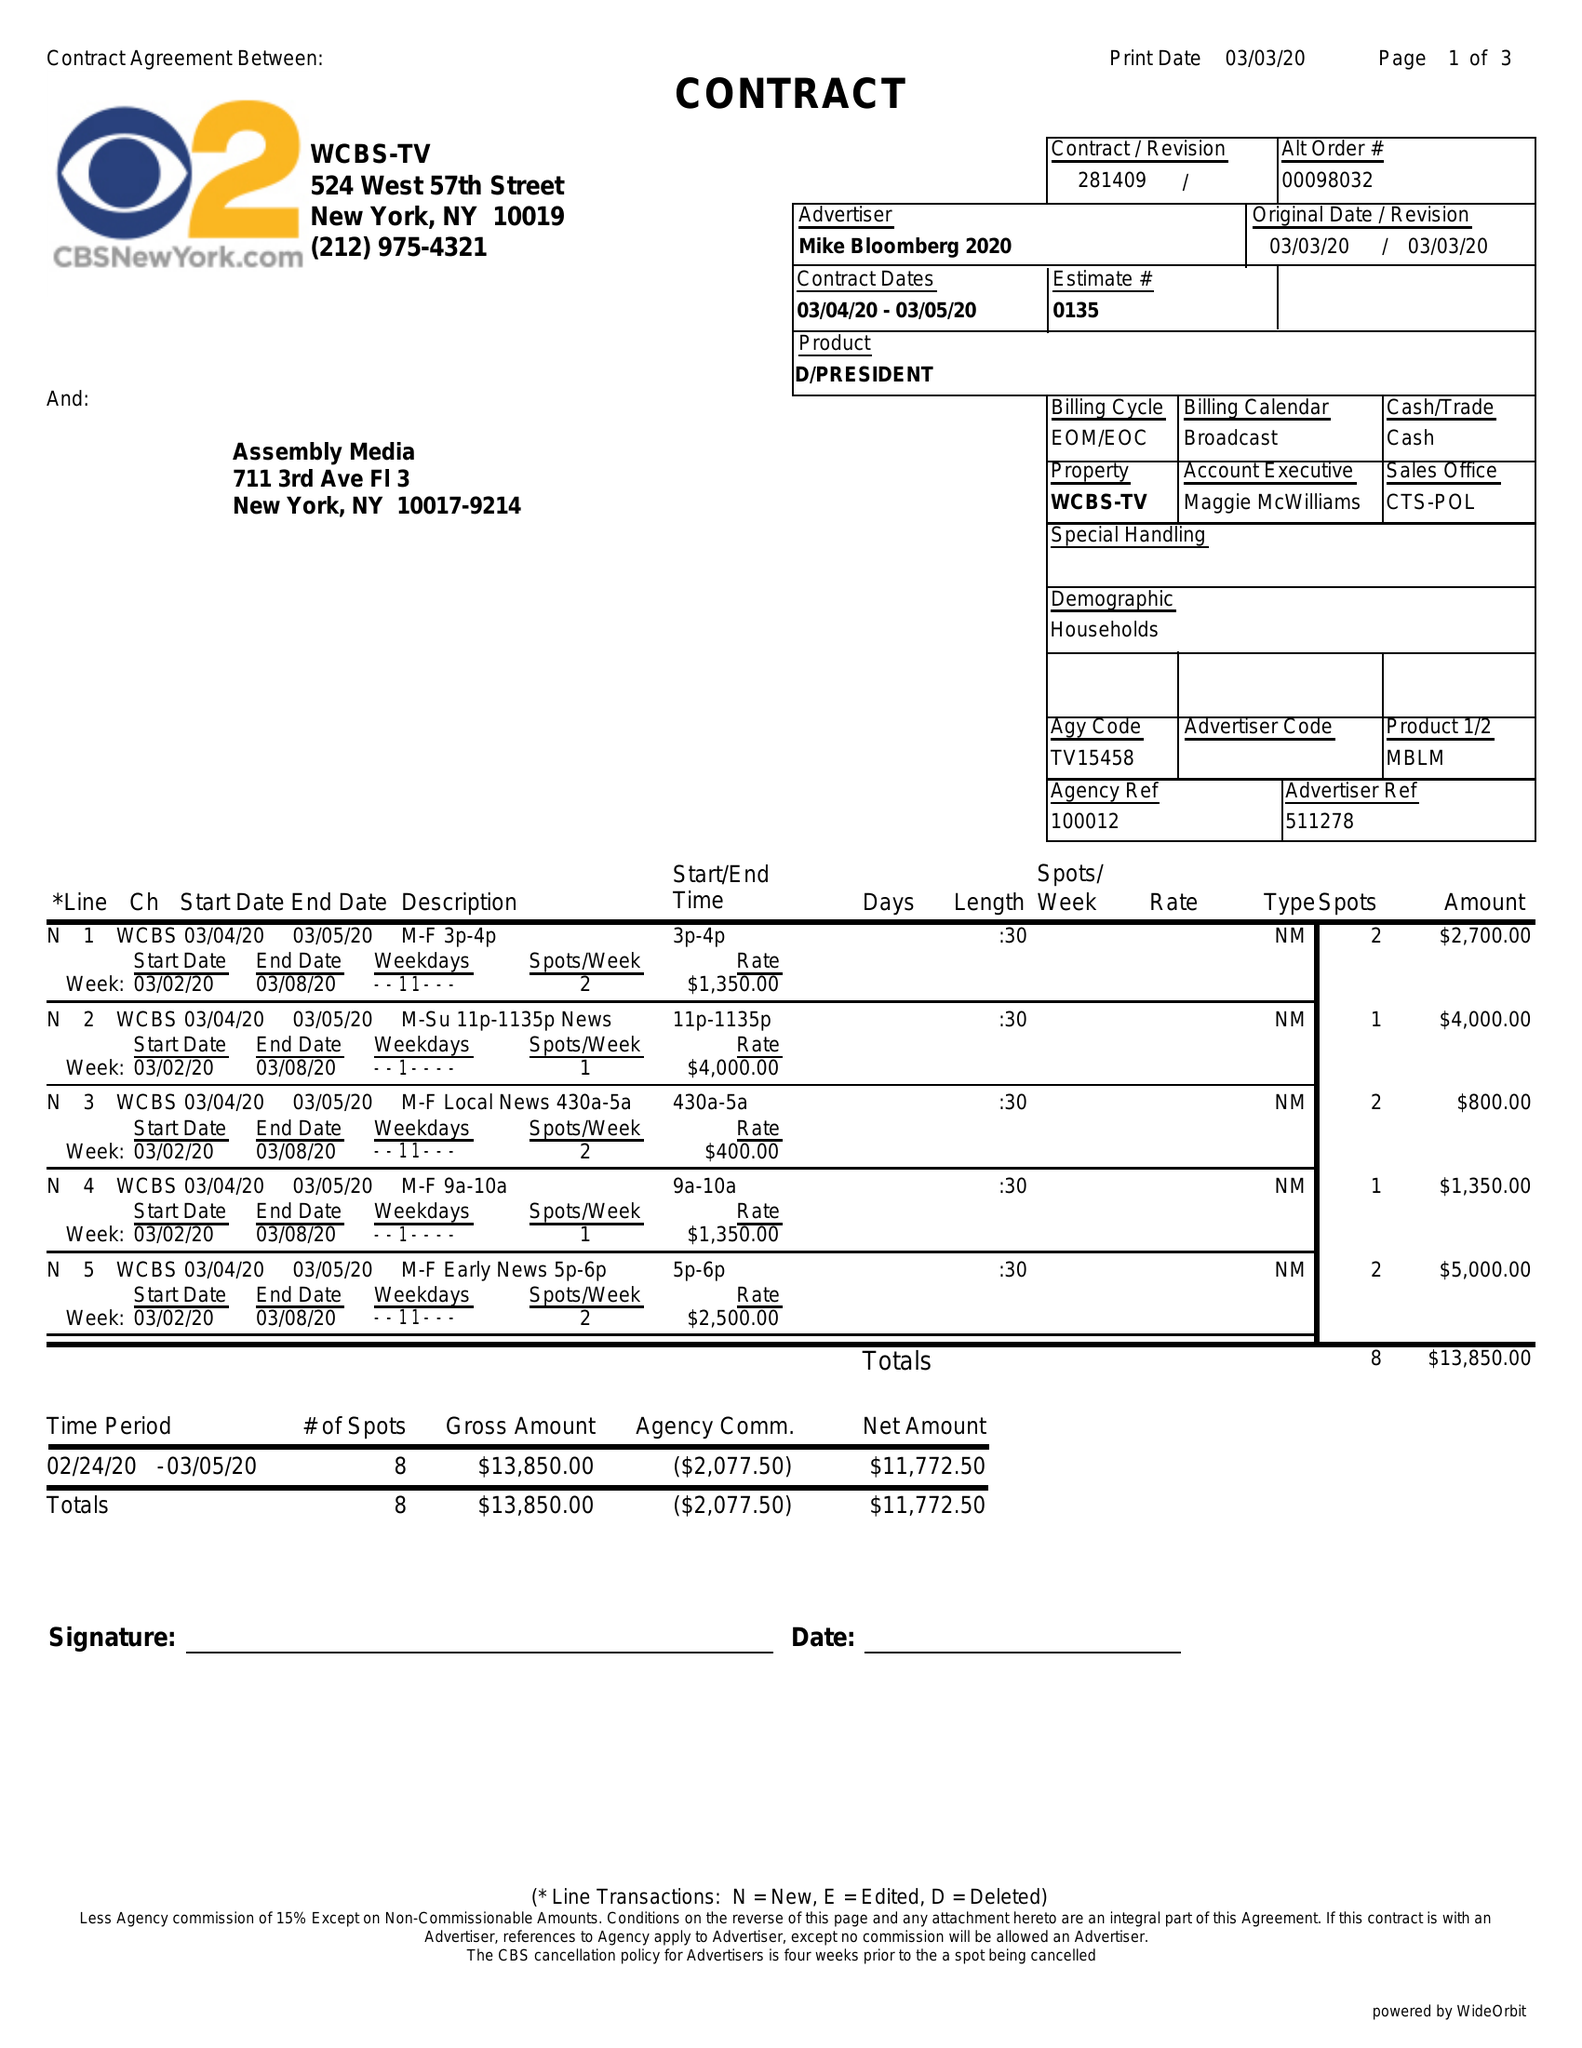What is the value for the gross_amount?
Answer the question using a single word or phrase. 13850.00 